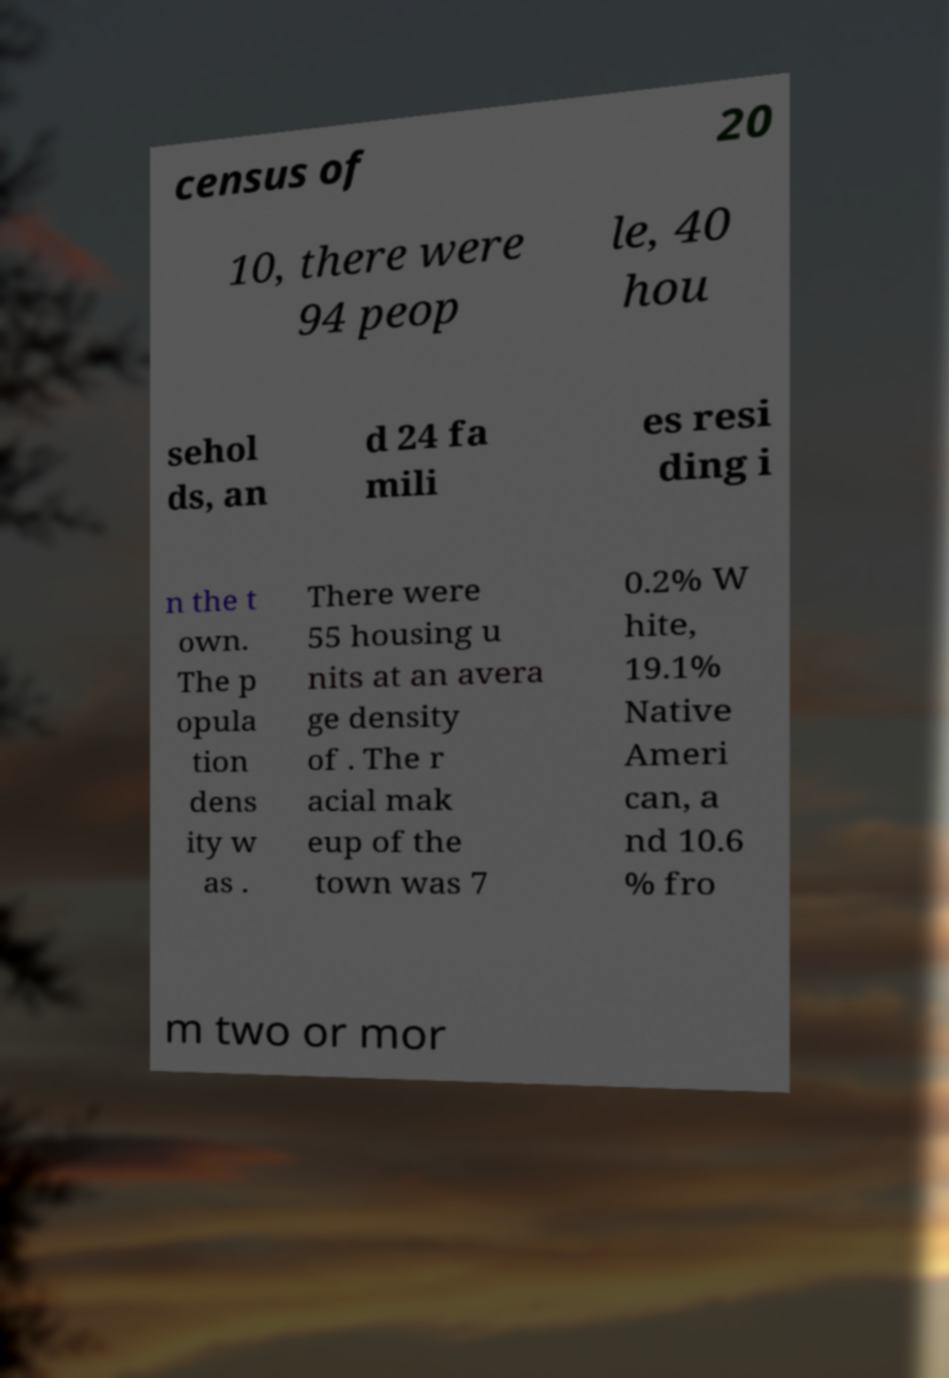Can you read and provide the text displayed in the image?This photo seems to have some interesting text. Can you extract and type it out for me? census of 20 10, there were 94 peop le, 40 hou sehol ds, an d 24 fa mili es resi ding i n the t own. The p opula tion dens ity w as . There were 55 housing u nits at an avera ge density of . The r acial mak eup of the town was 7 0.2% W hite, 19.1% Native Ameri can, a nd 10.6 % fro m two or mor 